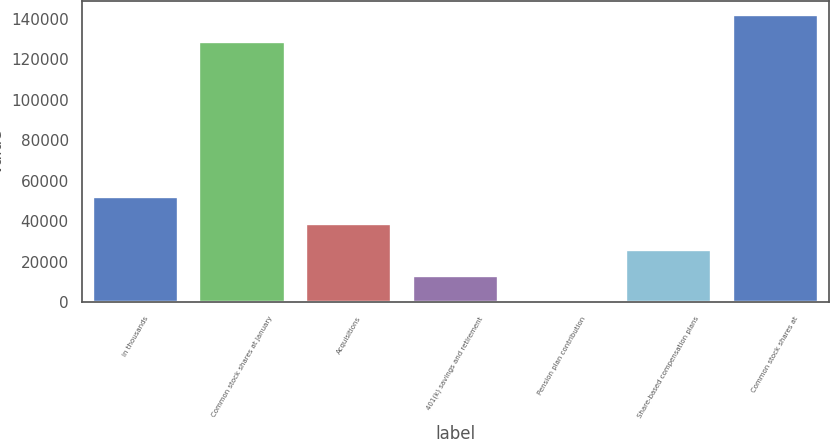Convert chart. <chart><loc_0><loc_0><loc_500><loc_500><bar_chart><fcel>in thousands<fcel>Common stock shares at January<fcel>Acquisitions<fcel>401(k) savings and retirement<fcel>Pension plan contribution<fcel>Share-based compensation plans<fcel>Common stock shares at<nl><fcel>51699.2<fcel>128570<fcel>38774.9<fcel>12926.3<fcel>2<fcel>25850.6<fcel>141494<nl></chart> 